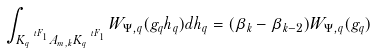Convert formula to latex. <formula><loc_0><loc_0><loc_500><loc_500>\int _ { K _ { q } ^ { \ t F _ { 1 } } A _ { m , k } K _ { q } ^ { \ t F _ { 1 } } } W _ { \Psi , q } ( g _ { q } h _ { q } ) d h _ { q } = ( \beta _ { k } - \beta _ { k - 2 } ) W _ { \Psi , q } ( g _ { q } )</formula> 